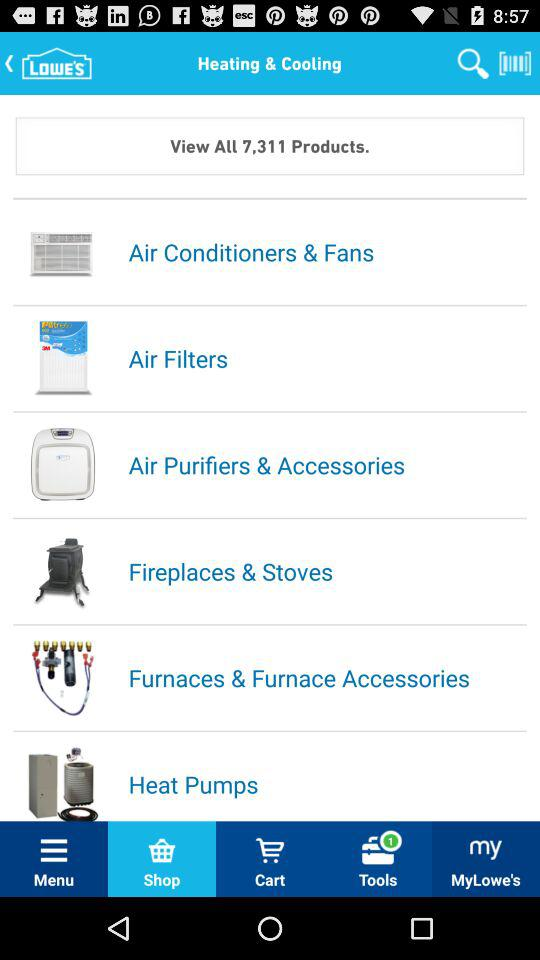How many products in total are there? There are 7,311 products in total. 